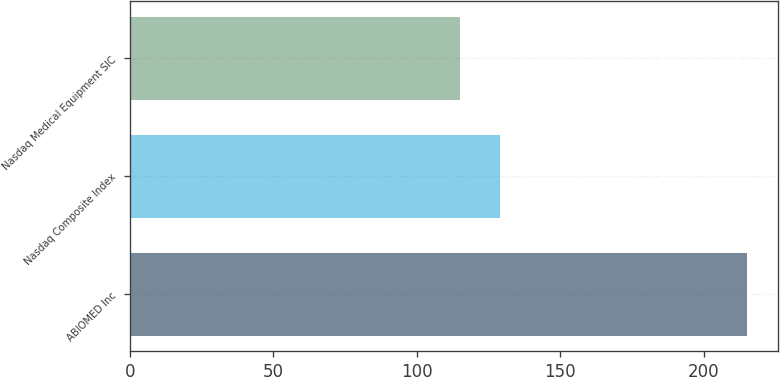<chart> <loc_0><loc_0><loc_500><loc_500><bar_chart><fcel>ABIOMED Inc<fcel>Nasdaq Composite Index<fcel>Nasdaq Medical Equipment SIC<nl><fcel>215.02<fcel>128.93<fcel>115.05<nl></chart> 